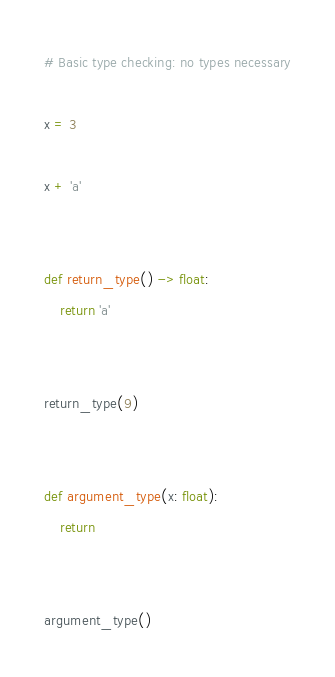<code> <loc_0><loc_0><loc_500><loc_500><_Python_># Basic type checking: no types necessary

x = 3

x + 'a'


def return_type() -> float:
    return 'a'


return_type(9)


def argument_type(x: float):
    return


argument_type()
</code> 